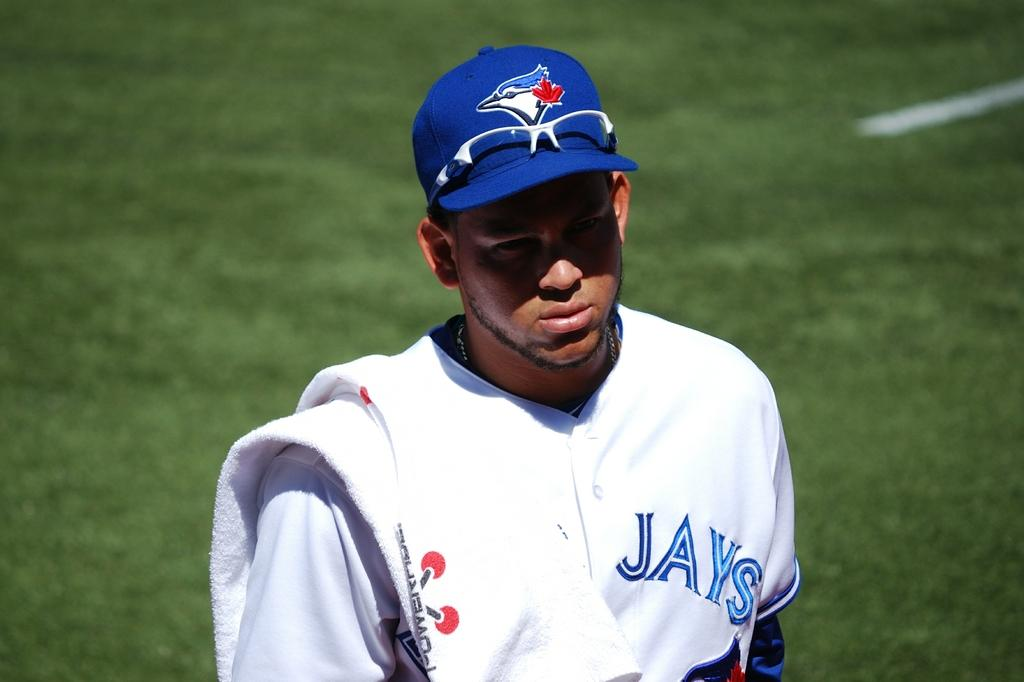<image>
Offer a succinct explanation of the picture presented. A man has Jays on his jersey and is wearing a blue hat. 